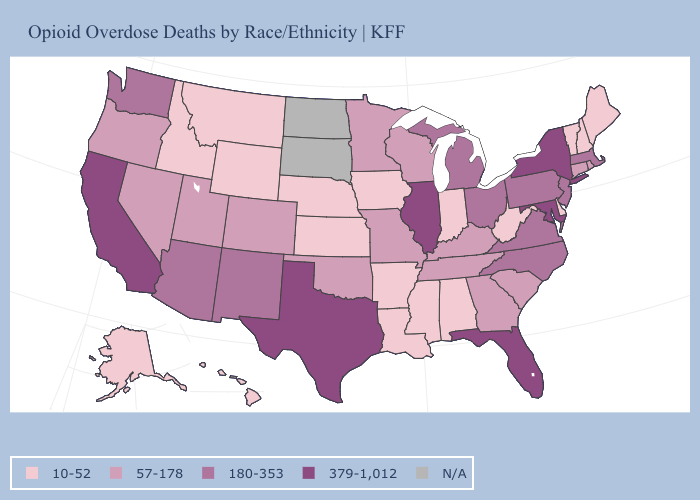Does Wyoming have the lowest value in the USA?
Be succinct. Yes. Is the legend a continuous bar?
Keep it brief. No. What is the lowest value in the MidWest?
Keep it brief. 10-52. Name the states that have a value in the range N/A?
Short answer required. North Dakota, South Dakota. Among the states that border New Mexico , which have the lowest value?
Short answer required. Colorado, Oklahoma, Utah. Does the first symbol in the legend represent the smallest category?
Quick response, please. Yes. Does the map have missing data?
Quick response, please. Yes. Does Wyoming have the lowest value in the West?
Short answer required. Yes. Name the states that have a value in the range 10-52?
Be succinct. Alabama, Alaska, Arkansas, Delaware, Hawaii, Idaho, Indiana, Iowa, Kansas, Louisiana, Maine, Mississippi, Montana, Nebraska, New Hampshire, Vermont, West Virginia, Wyoming. Is the legend a continuous bar?
Quick response, please. No. Among the states that border North Dakota , does Minnesota have the highest value?
Keep it brief. Yes. Name the states that have a value in the range N/A?
Keep it brief. North Dakota, South Dakota. What is the value of Pennsylvania?
Quick response, please. 180-353. 